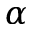<formula> <loc_0><loc_0><loc_500><loc_500>\alpha</formula> 